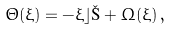<formula> <loc_0><loc_0><loc_500><loc_500>\Theta ( \xi ) = - \xi \rfloor \L + \Omega ( \xi ) \, ,</formula> 